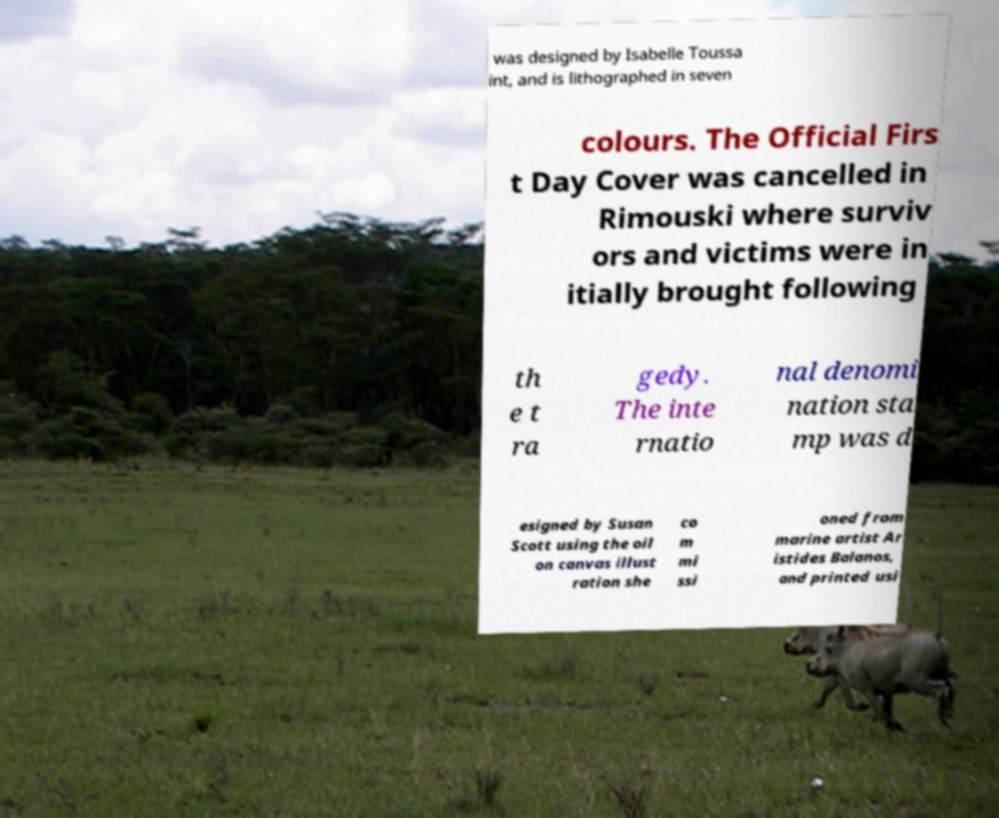Can you read and provide the text displayed in the image?This photo seems to have some interesting text. Can you extract and type it out for me? was designed by Isabelle Toussa int, and is lithographed in seven colours. The Official Firs t Day Cover was cancelled in Rimouski where surviv ors and victims were in itially brought following th e t ra gedy. The inte rnatio nal denomi nation sta mp was d esigned by Susan Scott using the oil on canvas illust ration she co m mi ssi oned from marine artist Ar istides Balanos, and printed usi 